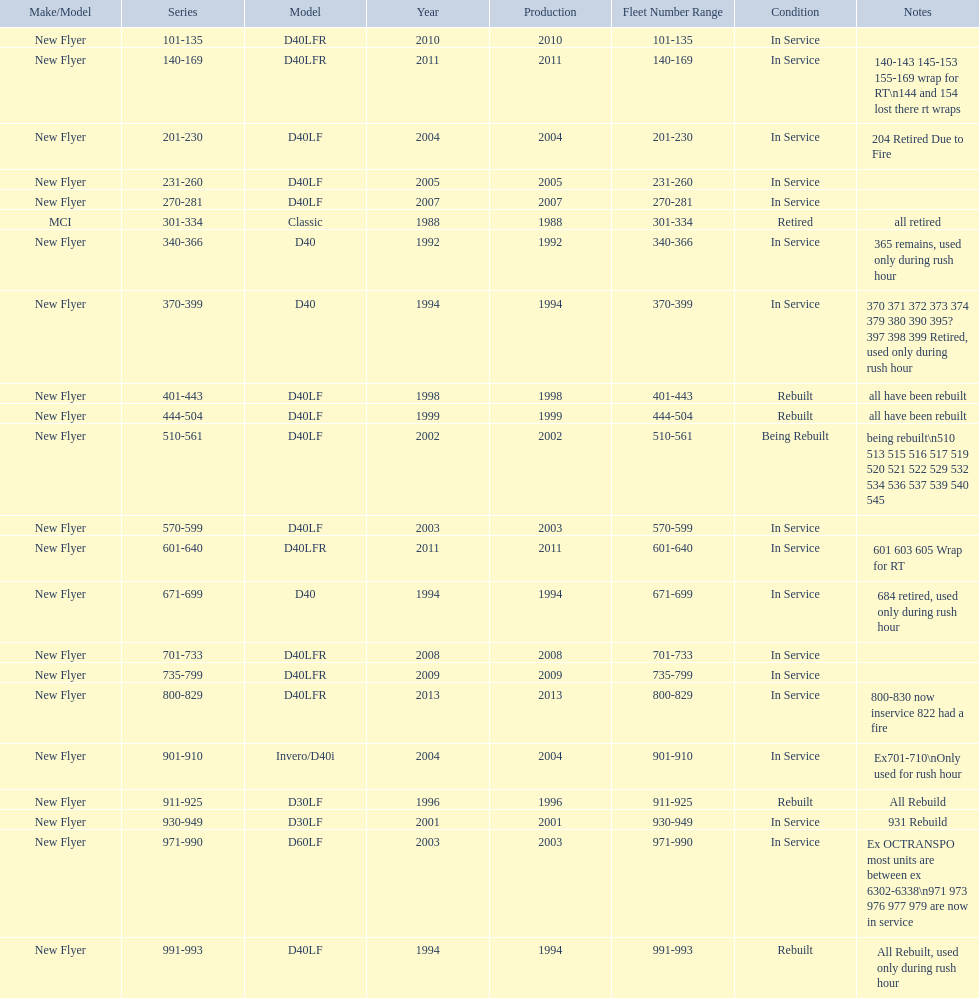Could you help me parse every detail presented in this table? {'header': ['Make/Model', 'Series', 'Model', 'Year', 'Production', 'Fleet Number Range', 'Condition', 'Notes'], 'rows': [['New Flyer', '101-135', 'D40LFR', '2010', '2010', '101-135', 'In Service', ''], ['New Flyer', '140-169', 'D40LFR', '2011', '2011', '140-169', 'In Service', '140-143 145-153 155-169 wrap for RT\\n144 and 154 lost there rt wraps'], ['New Flyer', '201-230', 'D40LF', '2004', '2004', '201-230', 'In Service', '204 Retired Due to Fire'], ['New Flyer', '231-260', 'D40LF', '2005', '2005', '231-260', 'In Service', ''], ['New Flyer', '270-281', 'D40LF', '2007', '2007', '270-281', 'In Service', ''], ['MCI', '301-334', 'Classic', '1988', '1988', '301-334', 'Retired', 'all retired'], ['New Flyer', '340-366', 'D40', '1992', '1992', '340-366', 'In Service', '365 remains, used only during rush hour'], ['New Flyer', '370-399', 'D40', '1994', '1994', '370-399', 'In Service', '370 371 372 373 374 379 380 390 395? 397 398 399 Retired, used only during rush hour'], ['New Flyer', '401-443', 'D40LF', '1998', '1998', '401-443', 'Rebuilt', 'all have been rebuilt'], ['New Flyer', '444-504', 'D40LF', '1999', '1999', '444-504', 'Rebuilt', 'all have been rebuilt'], ['New Flyer', '510-561', 'D40LF', '2002', '2002', '510-561', 'Being Rebuilt', 'being rebuilt\\n510 513 515 516 517 519 520 521 522 529 532 534 536 537 539 540 545'], ['New Flyer', '570-599', 'D40LF', '2003', '2003', '570-599', 'In Service', ''], ['New Flyer', '601-640', 'D40LFR', '2011', '2011', '601-640', 'In Service', '601 603 605 Wrap for RT'], ['New Flyer', '671-699', 'D40', '1994', '1994', '671-699', 'In Service', '684 retired, used only during rush hour'], ['New Flyer', '701-733', 'D40LFR', '2008', '2008', '701-733', 'In Service', ''], ['New Flyer', '735-799', 'D40LFR', '2009', '2009', '735-799', 'In Service', ''], ['New Flyer', '800-829', 'D40LFR', '2013', '2013', '800-829', 'In Service', '800-830 now inservice 822 had a fire'], ['New Flyer', '901-910', 'Invero/D40i', '2004', '2004', '901-910', 'In Service', 'Ex701-710\\nOnly used for rush hour'], ['New Flyer', '911-925', 'D30LF', '1996', '1996', '911-925', 'Rebuilt', 'All Rebuild'], ['New Flyer', '930-949', 'D30LF', '2001', '2001', '930-949', 'In Service', '931 Rebuild'], ['New Flyer', '971-990', 'D60LF', '2003', '2003', '971-990', 'In Service', 'Ex OCTRANSPO most units are between ex 6302-6338\\n971 973 976 977 979 are now in service'], ['New Flyer', '991-993', 'D40LF', '1994', '1994', '991-993', 'Rebuilt', 'All Rebuilt, used only during rush hour']]} What are all the models of buses? D40LFR, D40LF, Classic, D40, Invero/D40i, D30LF, D60LF. Of these buses, which series is the oldest? 301-334. Which is the  newest? 800-829. 